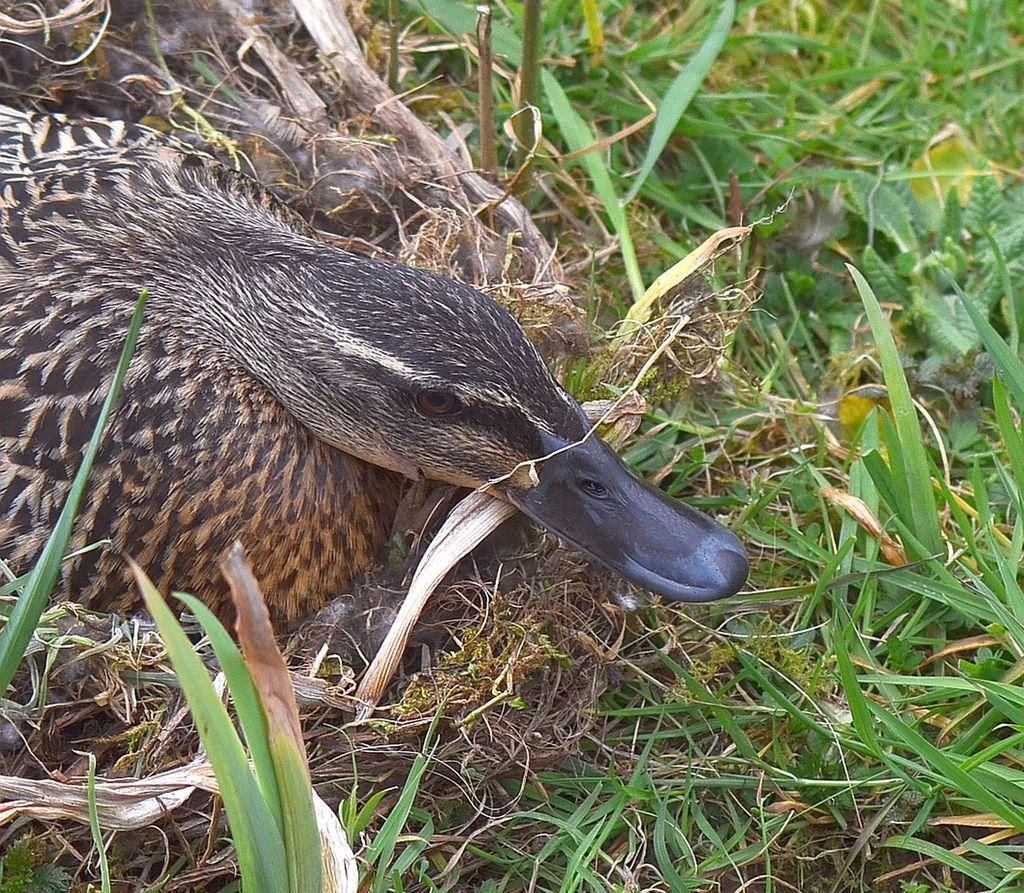What type of animal is in the image? There is a duck in the image. What type of vegetation is present in the image? There is grass and a plant in the image. What type of quarter is visible in the image? There is no quarter present in the image. What type of trousers is the duck wearing in the image? Ducks do not wear trousers, and there is no clothing visible in the image. 